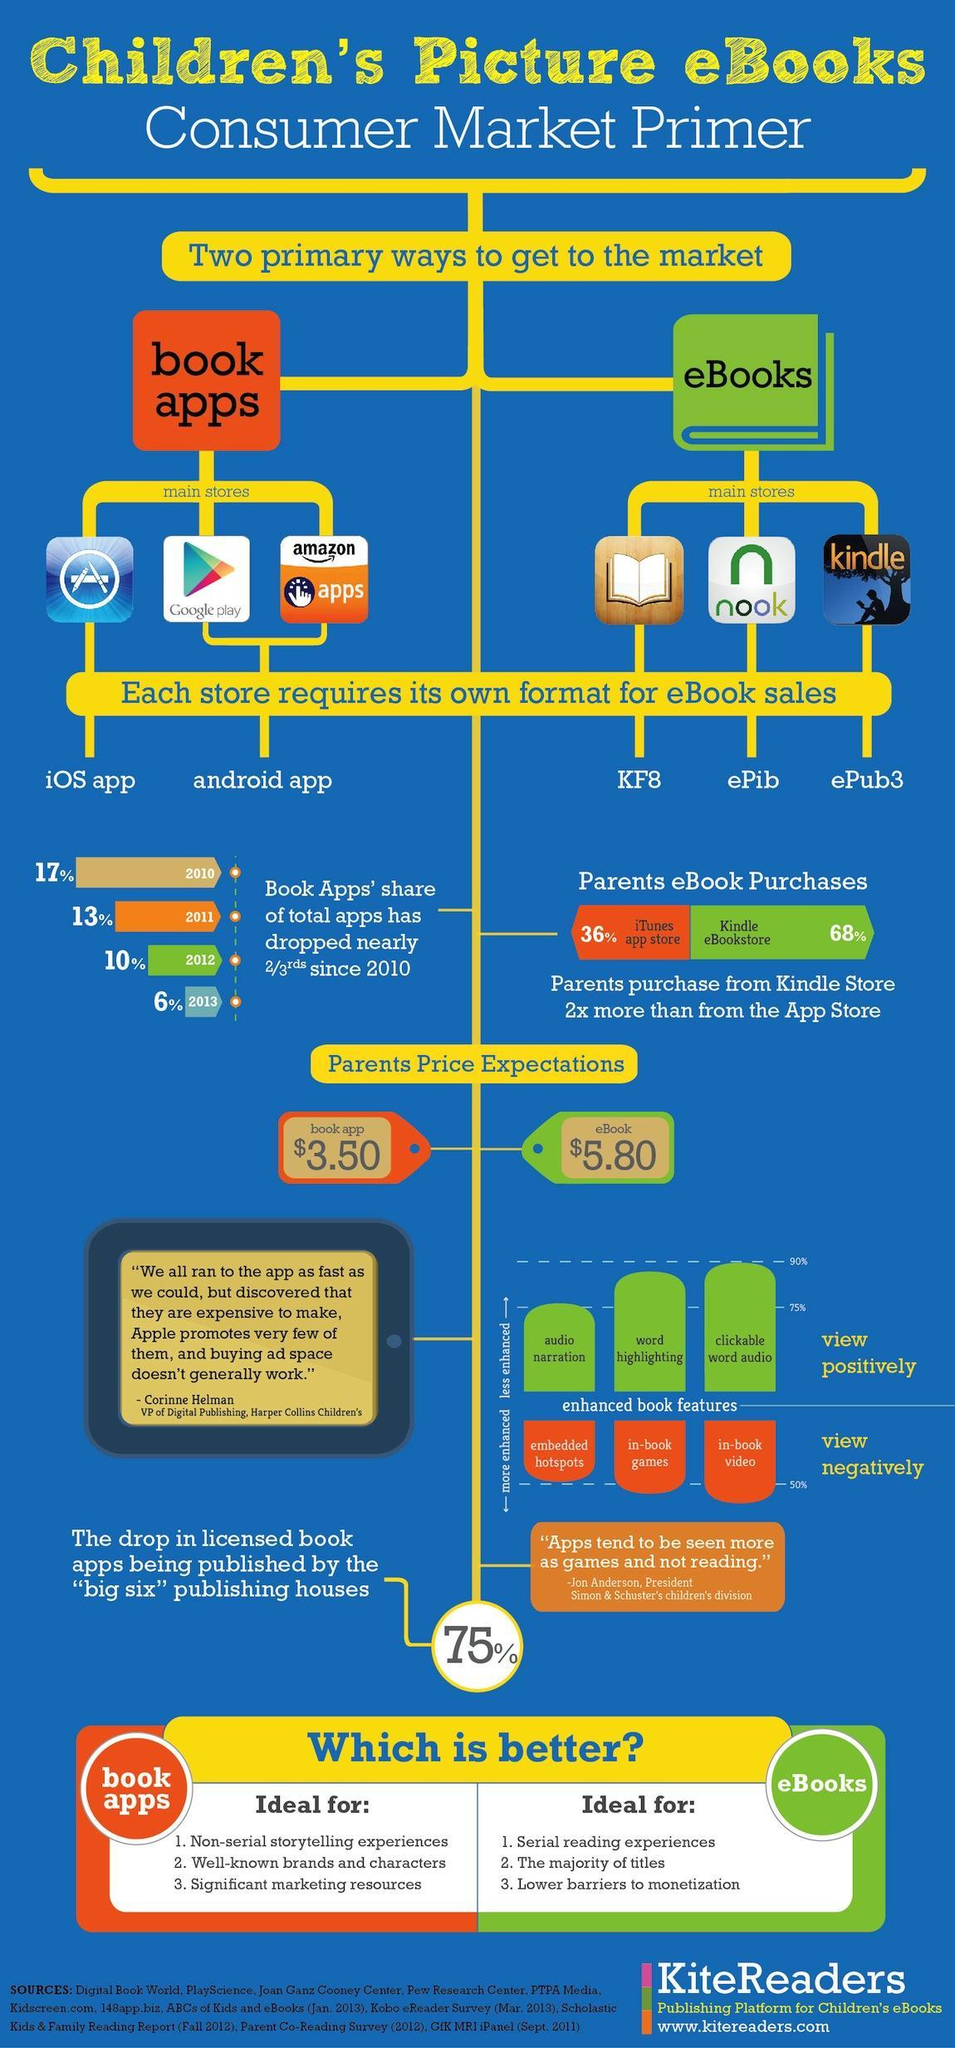What is the format of the Nook store?
Answer the question with a short phrase. ePib What is the parent's price expectation for book app and eBook, taken together? 9.3 What is the format of the Kindle store? ePub3 